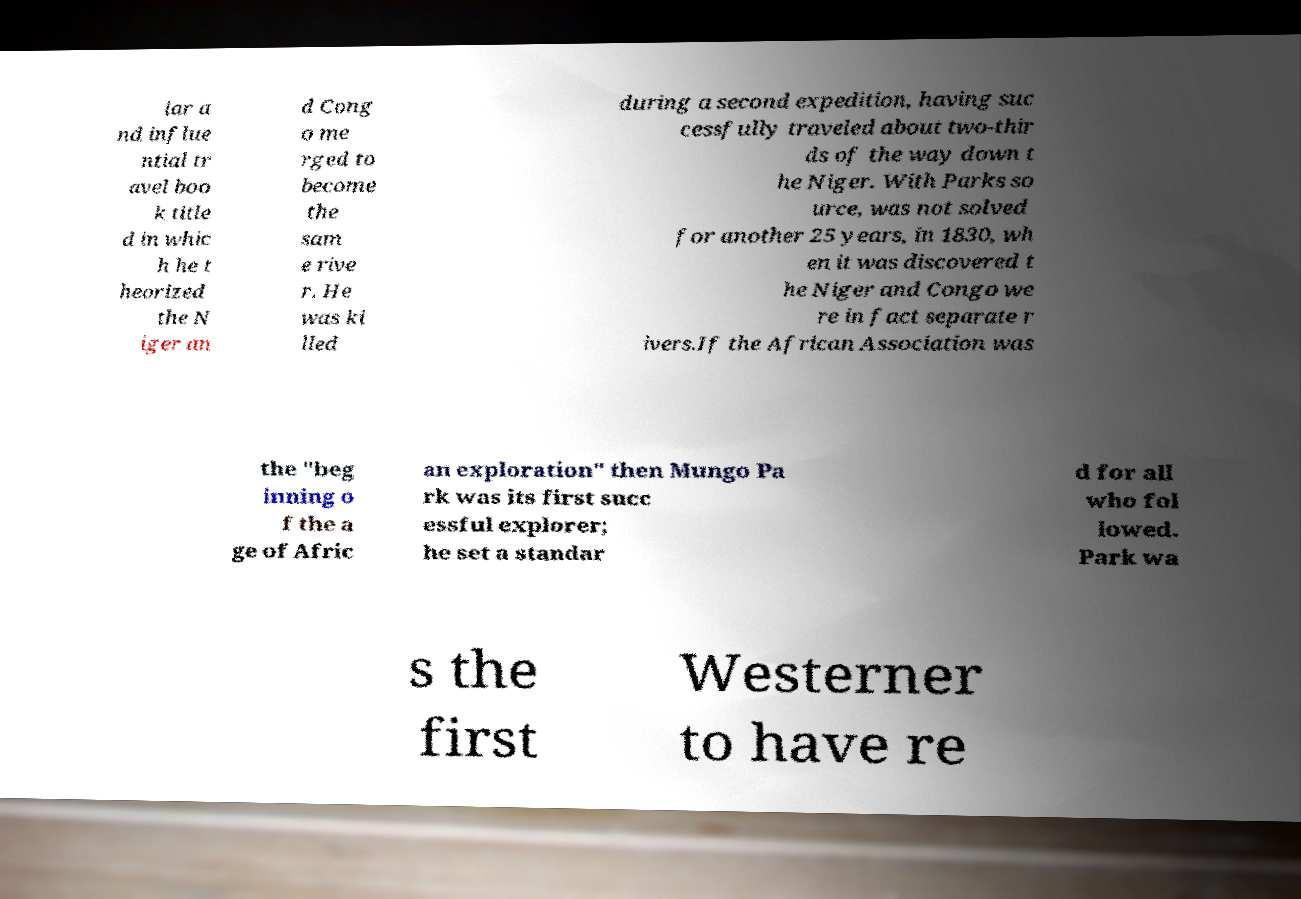Please read and relay the text visible in this image. What does it say? lar a nd influe ntial tr avel boo k title d in whic h he t heorized the N iger an d Cong o me rged to become the sam e rive r. He was ki lled during a second expedition, having suc cessfully traveled about two-thir ds of the way down t he Niger. With Parks so urce, was not solved for another 25 years, in 1830, wh en it was discovered t he Niger and Congo we re in fact separate r ivers.If the African Association was the "beg inning o f the a ge of Afric an exploration" then Mungo Pa rk was its first succ essful explorer; he set a standar d for all who fol lowed. Park wa s the first Westerner to have re 